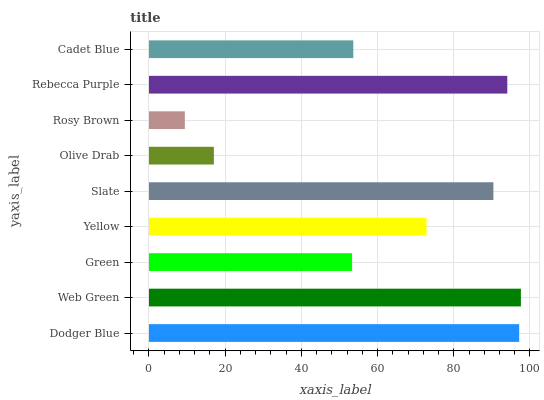Is Rosy Brown the minimum?
Answer yes or no. Yes. Is Web Green the maximum?
Answer yes or no. Yes. Is Green the minimum?
Answer yes or no. No. Is Green the maximum?
Answer yes or no. No. Is Web Green greater than Green?
Answer yes or no. Yes. Is Green less than Web Green?
Answer yes or no. Yes. Is Green greater than Web Green?
Answer yes or no. No. Is Web Green less than Green?
Answer yes or no. No. Is Yellow the high median?
Answer yes or no. Yes. Is Yellow the low median?
Answer yes or no. Yes. Is Olive Drab the high median?
Answer yes or no. No. Is Rebecca Purple the low median?
Answer yes or no. No. 